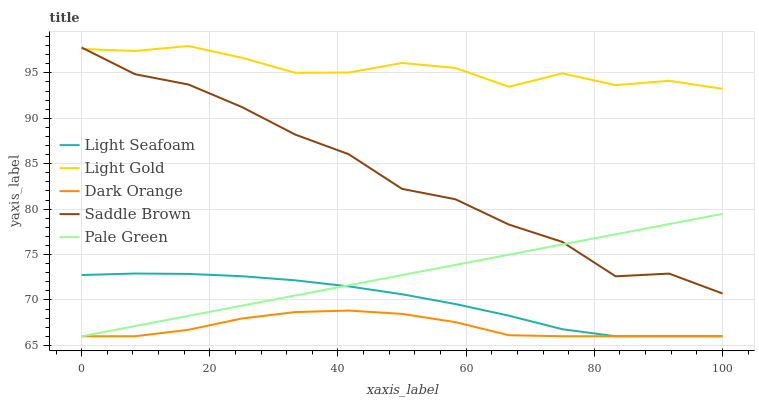Does Dark Orange have the minimum area under the curve?
Answer yes or no. Yes. Does Light Gold have the maximum area under the curve?
Answer yes or no. Yes. Does Pale Green have the minimum area under the curve?
Answer yes or no. No. Does Pale Green have the maximum area under the curve?
Answer yes or no. No. Is Pale Green the smoothest?
Answer yes or no. Yes. Is Saddle Brown the roughest?
Answer yes or no. Yes. Is Light Seafoam the smoothest?
Answer yes or no. No. Is Light Seafoam the roughest?
Answer yes or no. No. Does Dark Orange have the lowest value?
Answer yes or no. Yes. Does Light Gold have the lowest value?
Answer yes or no. No. Does Light Gold have the highest value?
Answer yes or no. Yes. Does Pale Green have the highest value?
Answer yes or no. No. Is Dark Orange less than Light Gold?
Answer yes or no. Yes. Is Light Gold greater than Light Seafoam?
Answer yes or no. Yes. Does Pale Green intersect Dark Orange?
Answer yes or no. Yes. Is Pale Green less than Dark Orange?
Answer yes or no. No. Is Pale Green greater than Dark Orange?
Answer yes or no. No. Does Dark Orange intersect Light Gold?
Answer yes or no. No. 